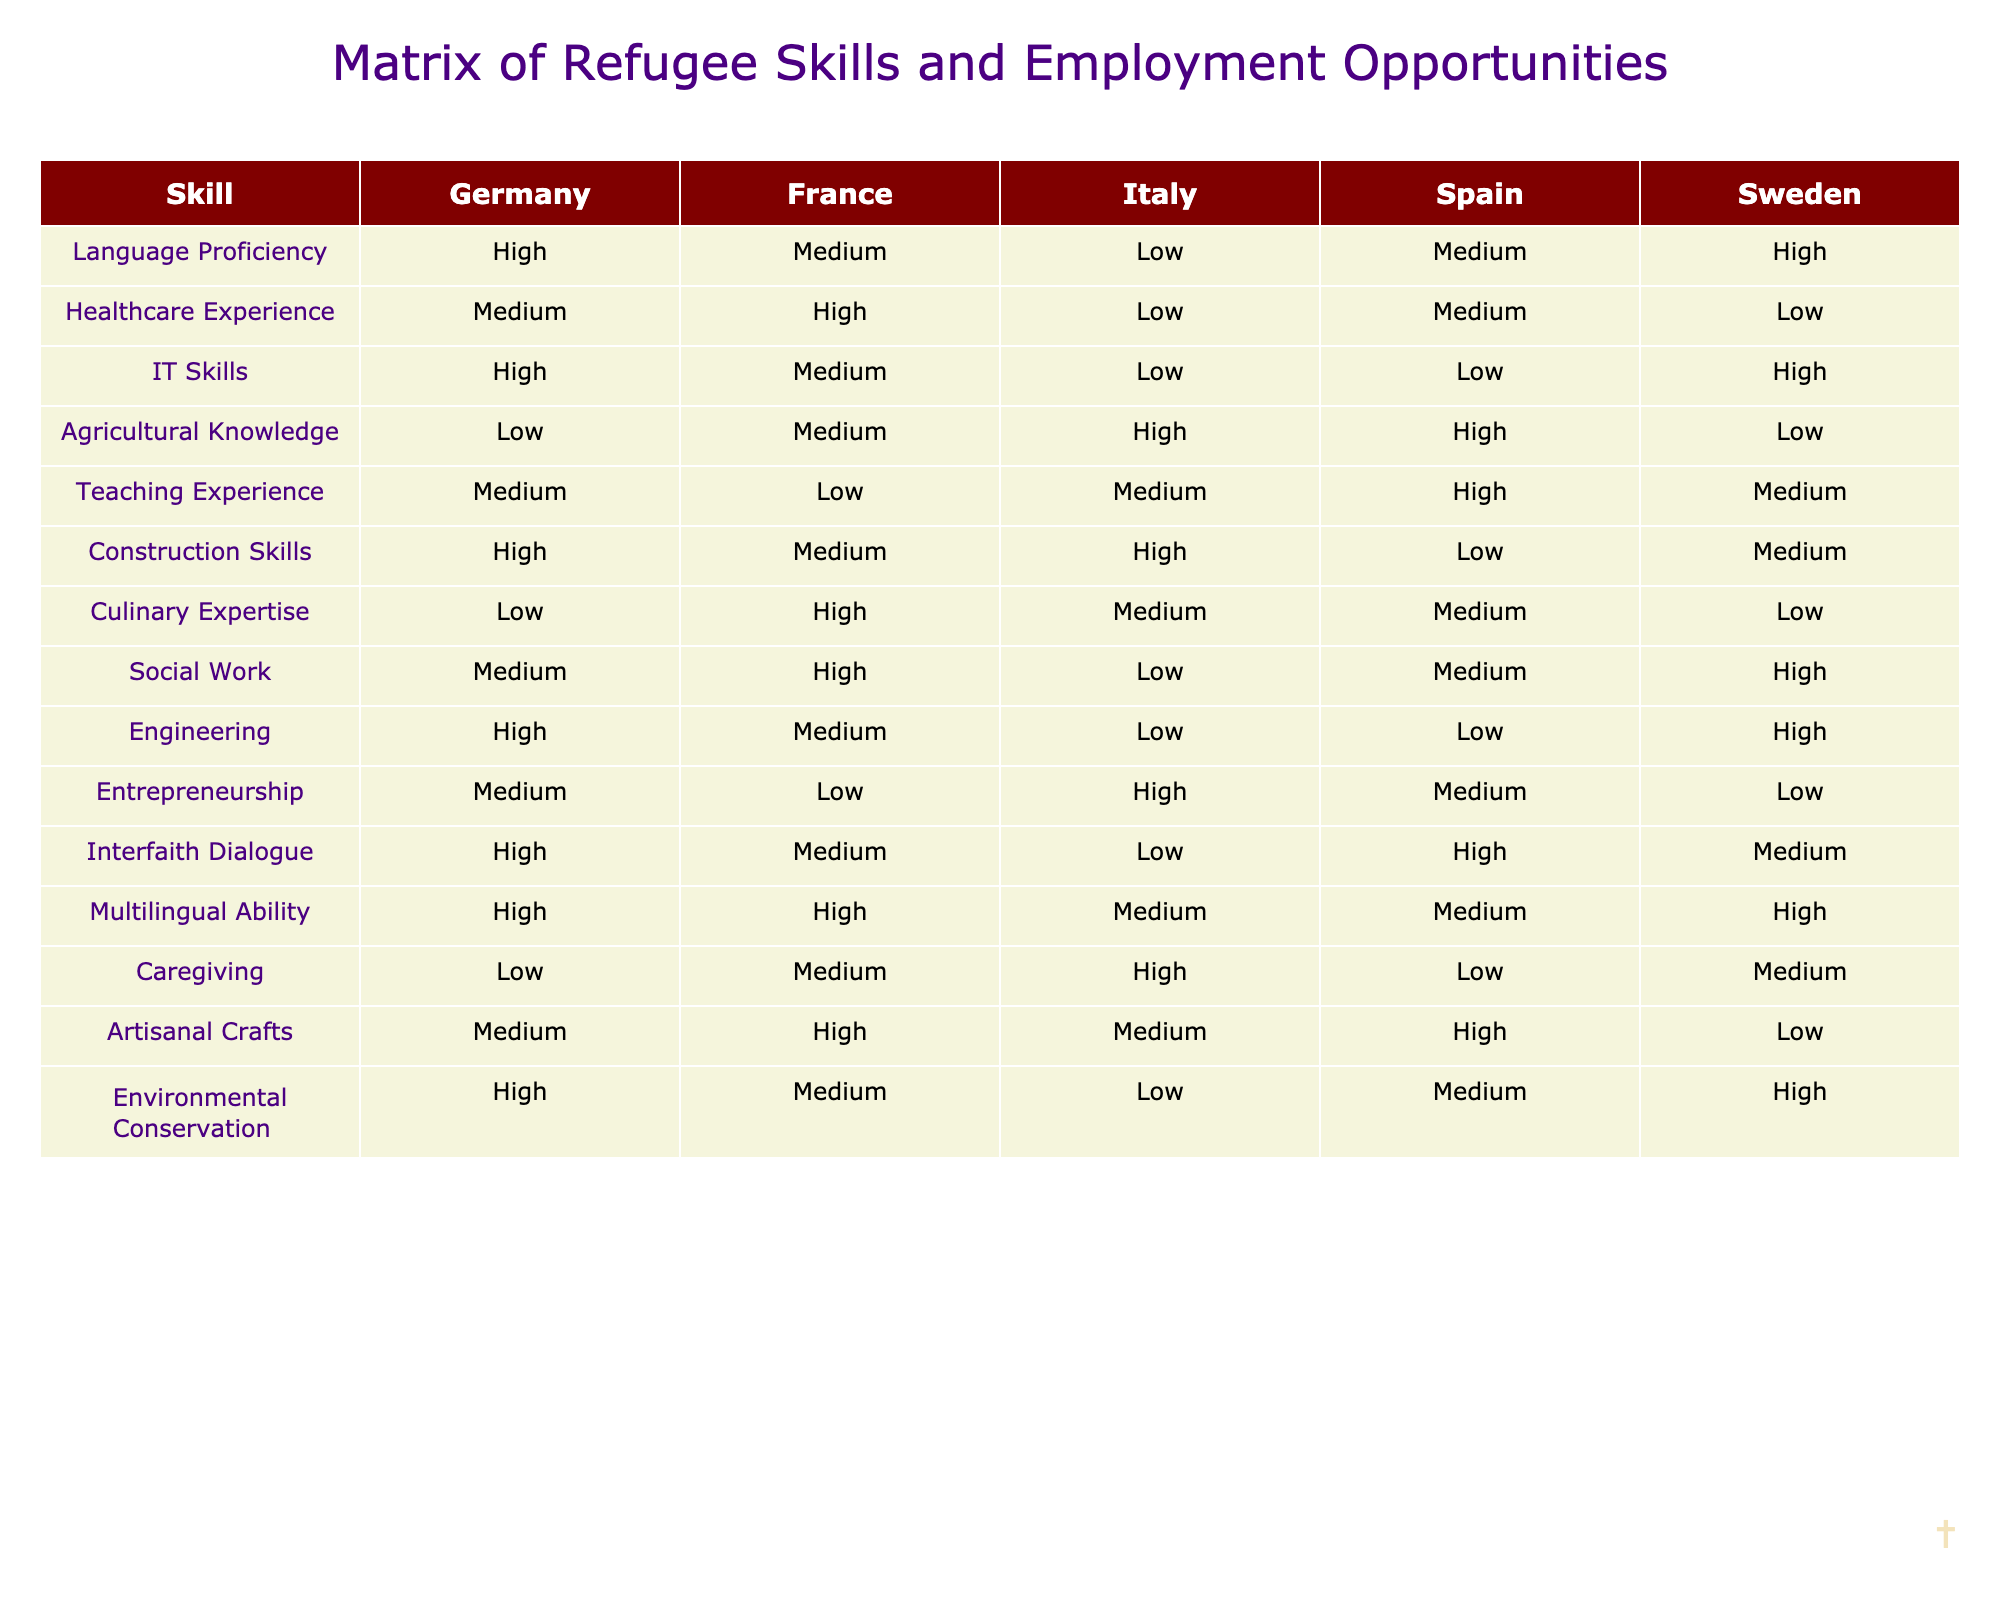What is the skill with the highest proficiency in Germany? According to the table, the skill that has 'High' proficiency in Germany is Language Proficiency, IT Skills, Construction Skills, Engineering, Multilingual Ability, and Environmental Conservation.
Answer: Language Proficiency, IT Skills, Construction Skills, Engineering, Multilingual Ability, Environmental Conservation Which country shows the lowest level of healthcare experience for refugees? The table indicates that the lowest proficiency level of healthcare experience is 'Low' in Italy and Sweden.
Answer: Italy and Sweden How many countries have 'High' proficiency in Teaching Experience? From the table, the countries with 'High' proficiency in Teaching Experience are Spain, thus there is only one country with this level.
Answer: 1 Is there any country where refugees have 'Low' culinary expertise? By examining the table, Italy and Sweden show 'Low' proficiency in culinary expertise for refugees.
Answer: Yes What would be the average proficiency level of Agricultural Knowledge across all countries? Counting the corresponding levels, we see that Italy and Spain are High (2), France is Medium (1), Germany and Sweden are Low (2). Then, the average can be derived as: (2*3 + 1*1 + 0*2)/5 = 0.8, which equates to approximately Medium.
Answer: Medium Are there more countries where refugees have 'High' proficiency in IT Skills than in Construction Skills? Reviewing the skills, we see that 'High' proficiency in IT Skills appears in Germany and Sweden (2) while Construction Skills has Germany and Italy (2). So, they are equal.
Answer: No Which of the skills shows the most consistent low proficiency across the highlighted countries? Looking at the data, Agricultural Knowledge shows Low proficiency in Germany and Sweden, thus presenting a consistently low percentage of acceptance across total.
Answer: Agricultural Knowledge What is the difference in the number of languages spoken at 'High' proficiency between Germany and France? In Germany, multi-lingual ability is 'High' while in France, it’s also 'High'. Therefore, there is no difference in the number of languages spoken at 'High' proficiency.
Answer: 0 In which country do refugees have 'Medium' proficiency in Social Work, but 'Low' proficiency in Agricultural Knowledge? If we analyze the data, we can see that refugees in France have 'Medium' proficiency in Social Work and 'Low' proficiency in Agricultural Knowledge.
Answer: France 